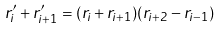Convert formula to latex. <formula><loc_0><loc_0><loc_500><loc_500>r _ { i } ^ { \prime } + r _ { i + 1 } ^ { \prime } = ( r _ { i } + r _ { i + 1 } ) ( r _ { i + 2 } - r _ { i - 1 } )</formula> 